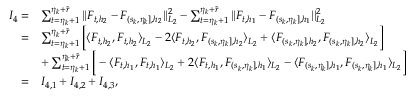<formula> <loc_0><loc_0><loc_500><loc_500>\begin{array} { r l } { I _ { 4 } = } & { \sum _ { t = \eta _ { k } + 1 } ^ { \eta _ { k } + \widetilde { r } } | | F _ { t , { h _ { 2 } } } - F _ { ( s _ { k } , \eta _ { k } ] , { h _ { 2 } } } | | _ { L _ { 2 } } ^ { 2 } - \sum _ { t = \eta _ { k } + 1 } ^ { \eta _ { k } + \widetilde { r } } | | F _ { t , { h _ { 1 } } } - F _ { ( s _ { k } , \eta _ { k } ] , { h _ { 1 } } } | | _ { L _ { 2 } } ^ { 2 } } \\ { = } & { \sum _ { t = \eta _ { k } + 1 } ^ { \eta _ { k } + \widetilde { r } } \left [ \langle F _ { t , h _ { 2 } } , F _ { t , h _ { 2 } } \rangle _ { L _ { 2 } } - 2 \langle F _ { t , h _ { 2 } } , F _ { ( s _ { k } , \eta _ { k } ] , { h _ { 2 } } } \rangle _ { L _ { 2 } } + \langle F _ { ( s _ { k } , \eta _ { k } ] , { h _ { 2 } } } , F _ { ( s _ { k } , \eta _ { k } ] , { h _ { 2 } } } \rangle _ { L _ { 2 } } \right ] } \\ & { + \sum _ { t = \eta _ { k } + 1 } ^ { \eta _ { k } + \widetilde { r } } \left [ - \langle F _ { t , h _ { 1 } } , F _ { t , h _ { 1 } } \rangle _ { L _ { 2 } } + 2 \langle F _ { t , h _ { 1 } } , F _ { ( s _ { k } , \eta _ { k } ] , { h _ { 1 } } } \rangle _ { L _ { 2 } } - \langle F _ { ( s _ { k } , \eta _ { k } ] , { h _ { 1 } } } , F _ { ( s _ { k } , \eta _ { k } ] , { h _ { 1 } } } \rangle _ { L _ { 2 } } \right ] } \\ { = } & { I _ { 4 , 1 } + I _ { 4 , 2 } + I _ { 4 , 3 } , } \end{array}</formula> 